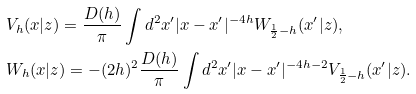Convert formula to latex. <formula><loc_0><loc_0><loc_500><loc_500>& V _ { h } ( x | z ) = \frac { D ( h ) } { \pi } \int d ^ { 2 } x ^ { \prime } | x - x ^ { \prime } | ^ { - 4 h } W _ { \frac { 1 } { 2 } - h } ( x ^ { \prime } | z ) , \\ & W _ { h } ( x | z ) = - ( 2 h ) ^ { 2 } \frac { D ( h ) } { \pi } \int d ^ { 2 } x ^ { \prime } | x - x ^ { \prime } | ^ { - 4 h - 2 } V _ { \frac { 1 } { 2 } - h } ( x ^ { \prime } | z ) .</formula> 